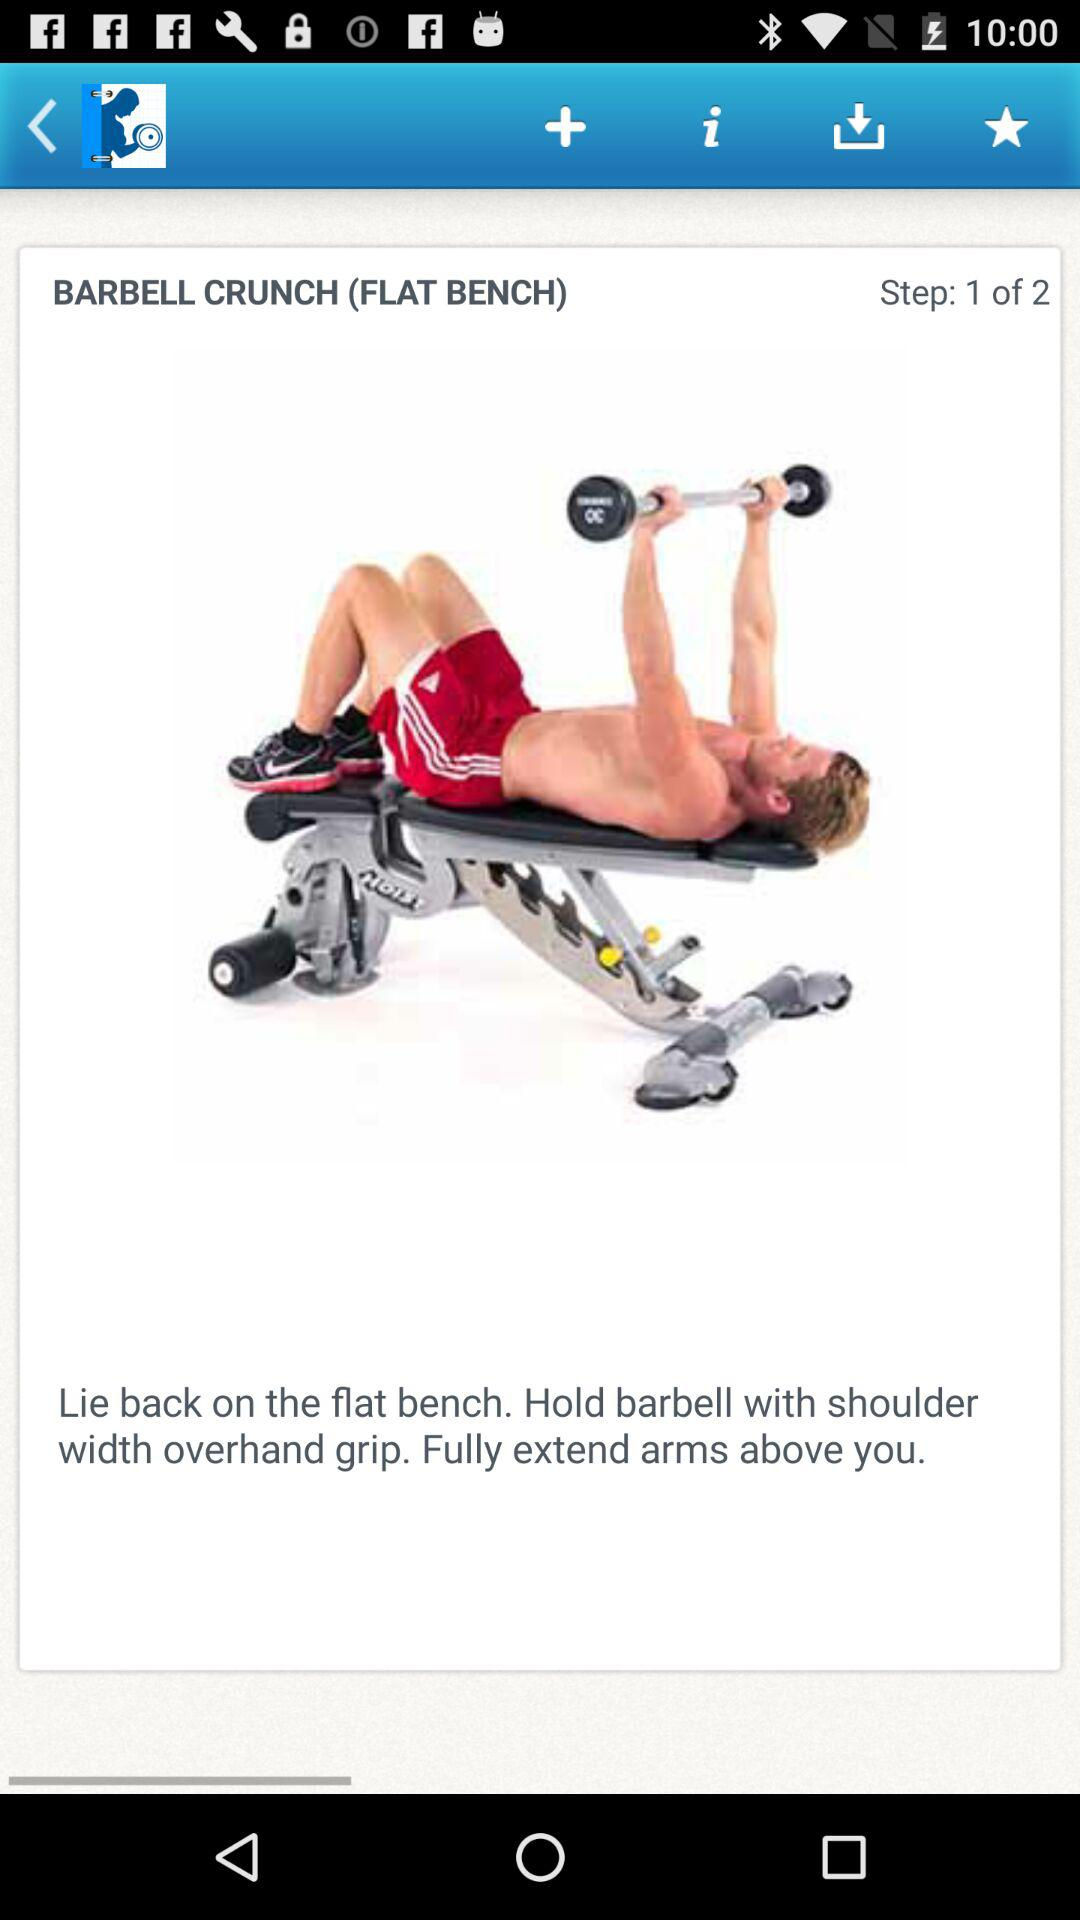How many steps are there in this exercise?
Answer the question using a single word or phrase. 2 